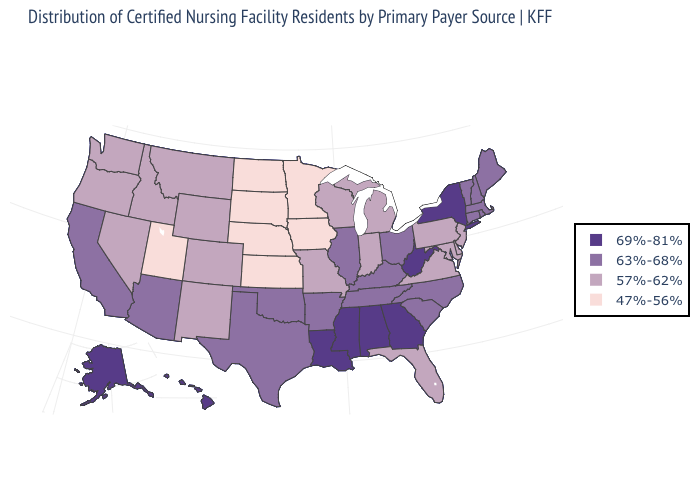Which states have the lowest value in the MidWest?
Answer briefly. Iowa, Kansas, Minnesota, Nebraska, North Dakota, South Dakota. Name the states that have a value in the range 47%-56%?
Write a very short answer. Iowa, Kansas, Minnesota, Nebraska, North Dakota, South Dakota, Utah. Name the states that have a value in the range 69%-81%?
Answer briefly. Alabama, Alaska, Georgia, Hawaii, Louisiana, Mississippi, New York, West Virginia. Among the states that border Idaho , does Nevada have the highest value?
Be succinct. Yes. Name the states that have a value in the range 57%-62%?
Be succinct. Colorado, Delaware, Florida, Idaho, Indiana, Maryland, Michigan, Missouri, Montana, Nevada, New Jersey, New Mexico, Oregon, Pennsylvania, Virginia, Washington, Wisconsin, Wyoming. Name the states that have a value in the range 47%-56%?
Answer briefly. Iowa, Kansas, Minnesota, Nebraska, North Dakota, South Dakota, Utah. Name the states that have a value in the range 69%-81%?
Answer briefly. Alabama, Alaska, Georgia, Hawaii, Louisiana, Mississippi, New York, West Virginia. Is the legend a continuous bar?
Keep it brief. No. What is the lowest value in states that border New Hampshire?
Be succinct. 63%-68%. Which states have the highest value in the USA?
Concise answer only. Alabama, Alaska, Georgia, Hawaii, Louisiana, Mississippi, New York, West Virginia. What is the value of Montana?
Quick response, please. 57%-62%. Name the states that have a value in the range 63%-68%?
Write a very short answer. Arizona, Arkansas, California, Connecticut, Illinois, Kentucky, Maine, Massachusetts, New Hampshire, North Carolina, Ohio, Oklahoma, Rhode Island, South Carolina, Tennessee, Texas, Vermont. What is the value of Idaho?
Keep it brief. 57%-62%. Name the states that have a value in the range 47%-56%?
Be succinct. Iowa, Kansas, Minnesota, Nebraska, North Dakota, South Dakota, Utah. Does the map have missing data?
Quick response, please. No. 